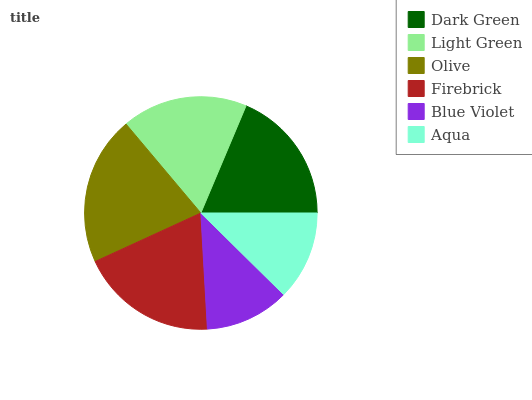Is Blue Violet the minimum?
Answer yes or no. Yes. Is Olive the maximum?
Answer yes or no. Yes. Is Light Green the minimum?
Answer yes or no. No. Is Light Green the maximum?
Answer yes or no. No. Is Dark Green greater than Light Green?
Answer yes or no. Yes. Is Light Green less than Dark Green?
Answer yes or no. Yes. Is Light Green greater than Dark Green?
Answer yes or no. No. Is Dark Green less than Light Green?
Answer yes or no. No. Is Dark Green the high median?
Answer yes or no. Yes. Is Light Green the low median?
Answer yes or no. Yes. Is Aqua the high median?
Answer yes or no. No. Is Dark Green the low median?
Answer yes or no. No. 